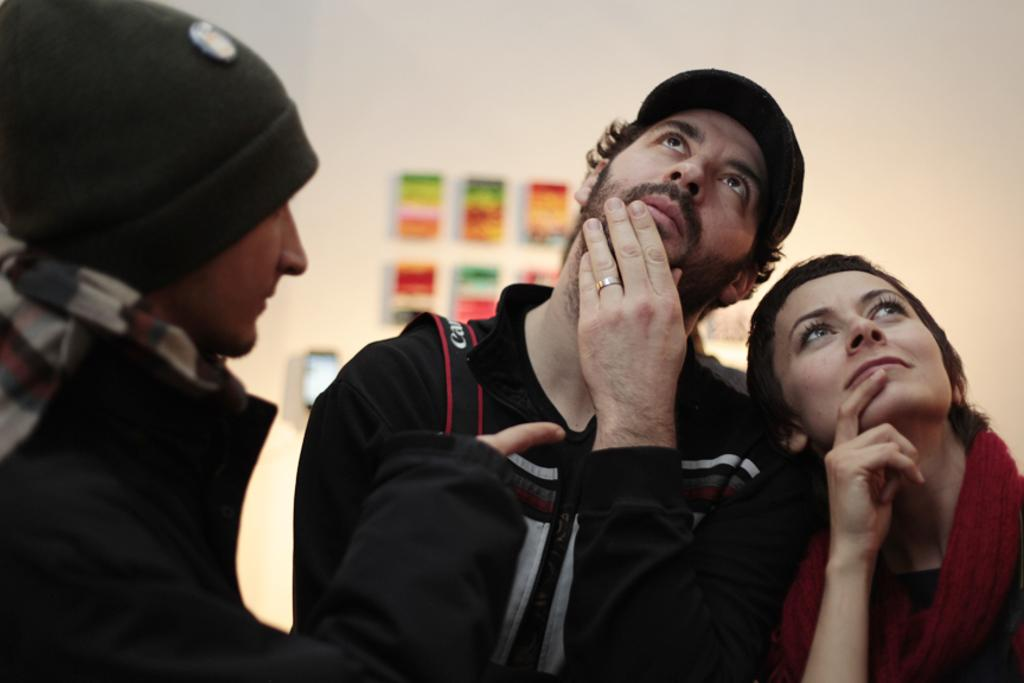Who or what can be seen in the image? There are people in the image. Can you describe anything in the background of the image? There is something on the wall in the background of the image. What type of milk is being poured from the tree in the image? There is no tree or milk present in the image. What kind of noise can be heard coming from the people in the image? The image does not provide any information about the sounds or noises in the scene, so it cannot be determined from the image. 